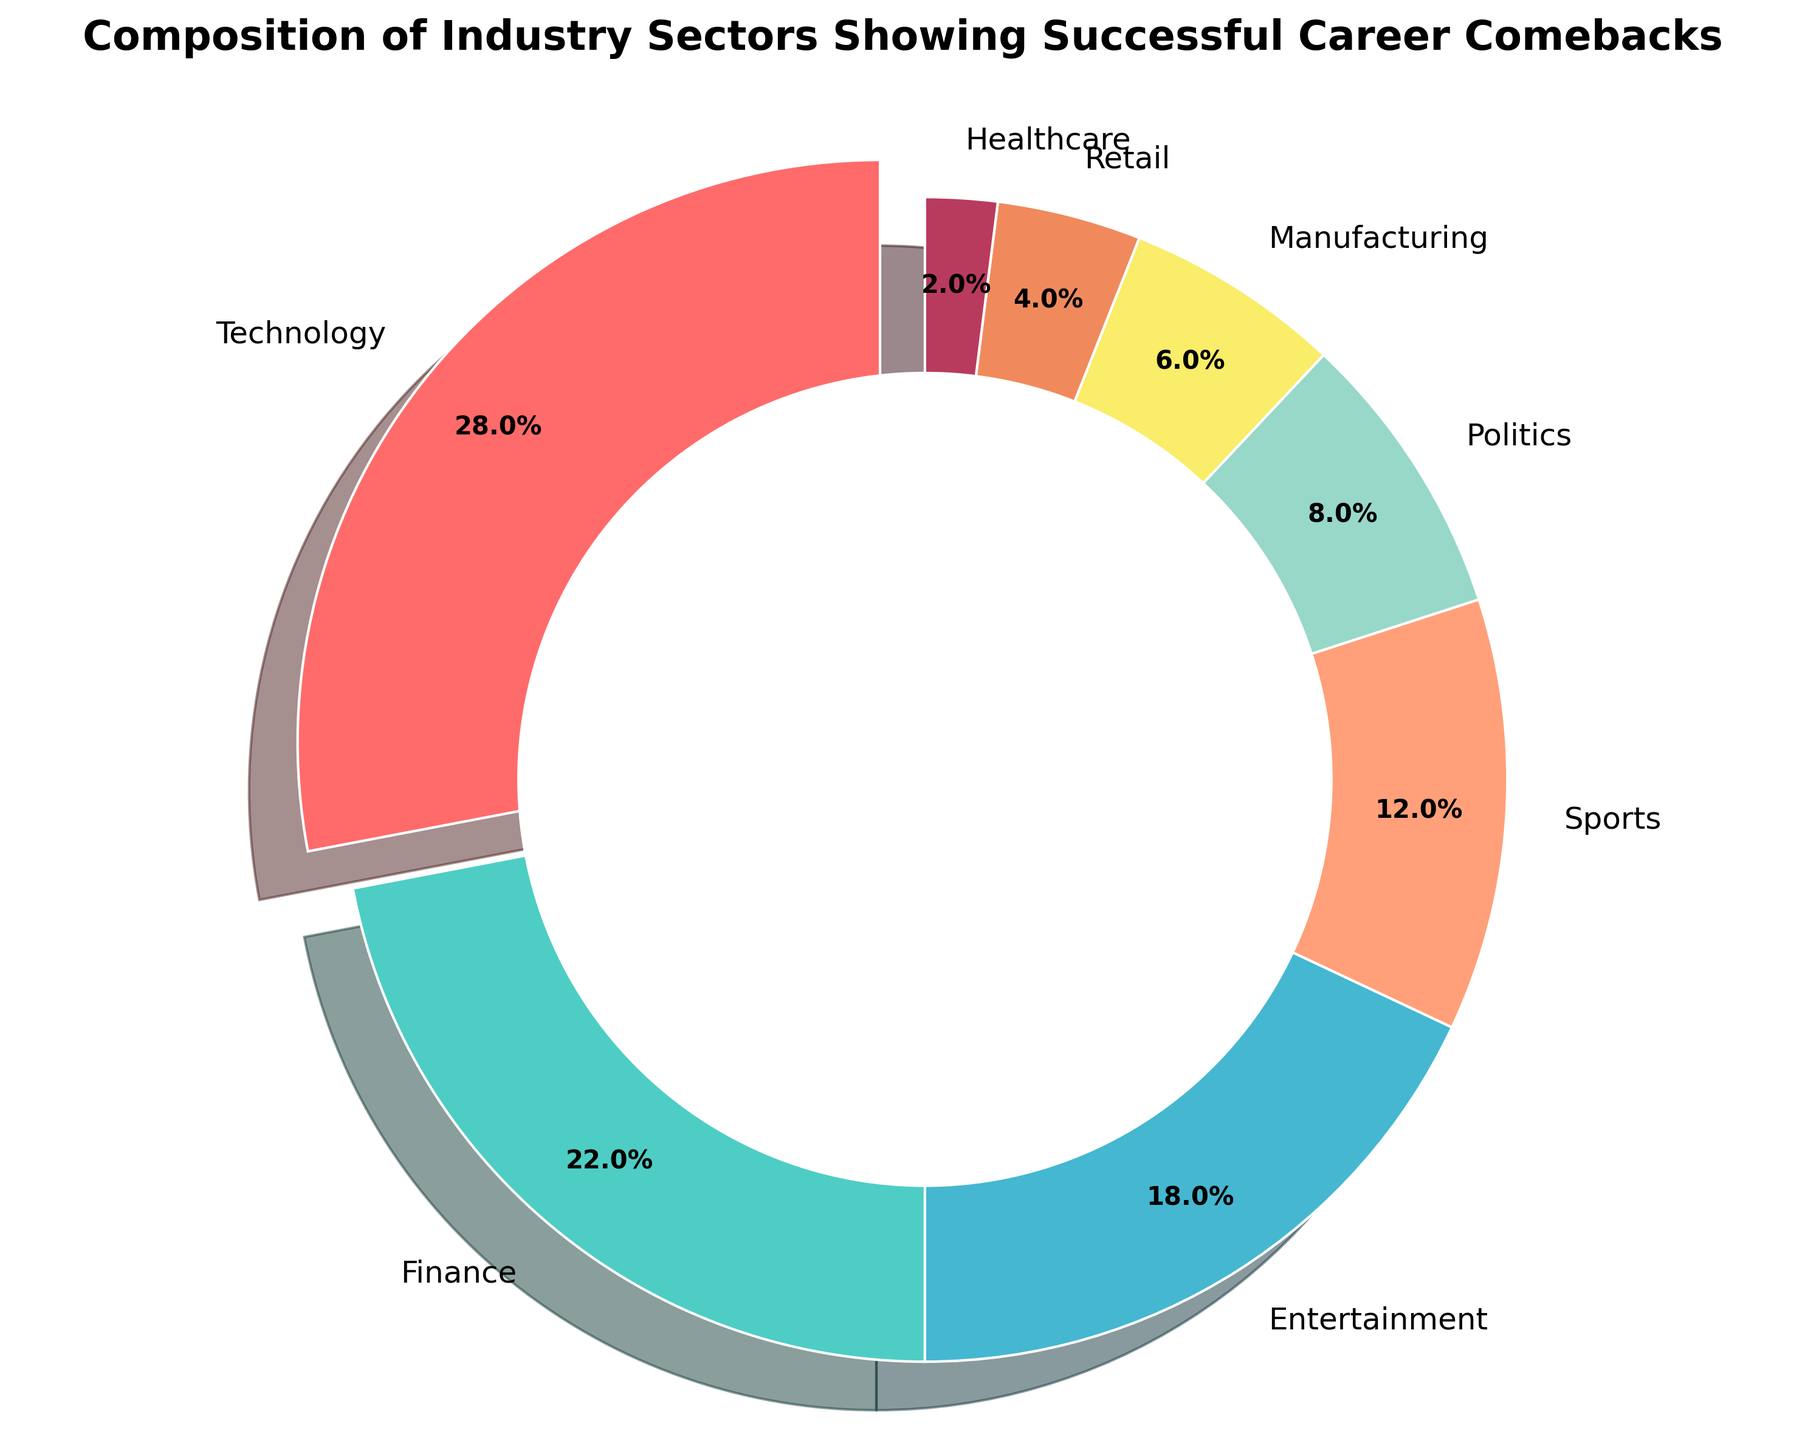What percentage of the total does the 'Technology' sector represent? The 'Technology' sector represents 28%. This is directly given as a data point on the pie chart.
Answer: 28% How much more does the 'Technology' sector represent compared to the 'Politics' sector? The 'Technology' sector represents 28%, and the 'Politics' sector represents 8%. The difference is 28% - 8% = 20%.
Answer: 20% Which sector has the smallest representation in the chart? The sector with the smallest representation in the chart has the smallest percentage value, which is 'Healthcare' with 2%.
Answer: Healthcare If you combine the 'Technology' and 'Finance' sectors, what fraction of the total do they represent? The 'Technology' sector is 28% and the 'Finance' sector is 22%. Combined, they represent 28% + 22% = 50% of the total.
Answer: 50% Does the 'Entertainment' sector have a higher or lower representation than the 'Sports' sector? The 'Entertainment' sector is represented by 18%, while the 'Sports' sector is represented by 12%. Therefore, the 'Entertainment' sector has a higher representation.
Answer: Higher What is the combined percentage representation of the 'Retail' and 'Manufacturing' sectors? The 'Retail' sector represents 4% and the 'Manufacturing' sector represents 6%. Together, they represent 4% + 6% = 10%.
Answer: 10% How does the percentage of the 'Entertainment' sector compare to the combined percentages of the 'Healthcare' and 'Retail' sectors? The 'Entertainment' sector is represented by 18%. The 'Healthcare' and 'Retail' sectors together are 2% + 4% = 6%. Therefore, the 'Entertainment' sector is larger by 18% - 6% = 12%.
Answer: 12% Which sector is represented by the light green color on the chart, and what is its percentage? The light green color on the chart corresponds to the 'Finance' sector, which represents 22% of the total.
Answer: Finance, 22% By how much does the 'Sports' sector percentage in the pie chart exceed the 'Healthcare' sector percentage? The 'Sports' sector is represented by 12%, while the 'Healthcare' sector is represented by 2%. The difference is 12% - 2% = 10%.
Answer: 10% Which sectors combined make up more than 50% of the total representation in the chart? The 'Technology' sector is 28% and the 'Finance' sector is 22%. Together they make up 28% + 22% = 50%. Adding any other sector would push the total above 50%. The most straightforward combination is 'Technology' and 'Finance'.
Answer: Technology and Finance 